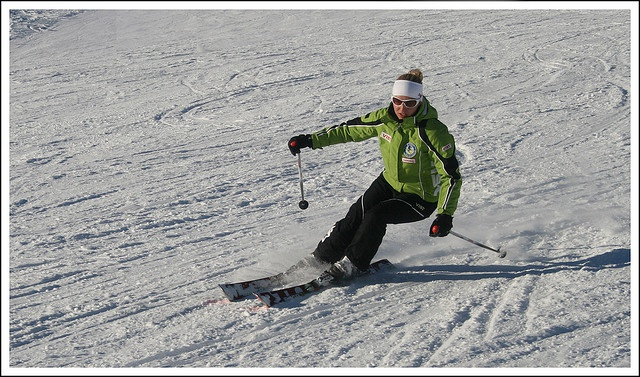Describe the objects in this image and their specific colors. I can see people in black, darkgreen, gray, and olive tones and skis in black, gray, darkgray, and darkblue tones in this image. 